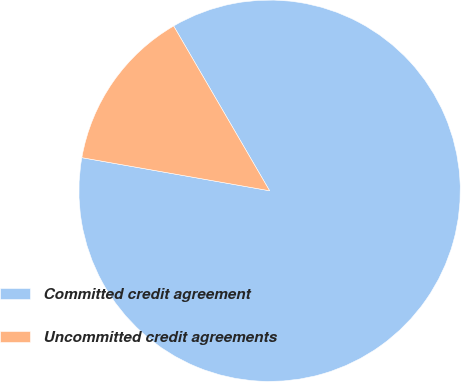<chart> <loc_0><loc_0><loc_500><loc_500><pie_chart><fcel>Committed credit agreement<fcel>Uncommitted credit agreements<nl><fcel>86.17%<fcel>13.83%<nl></chart> 